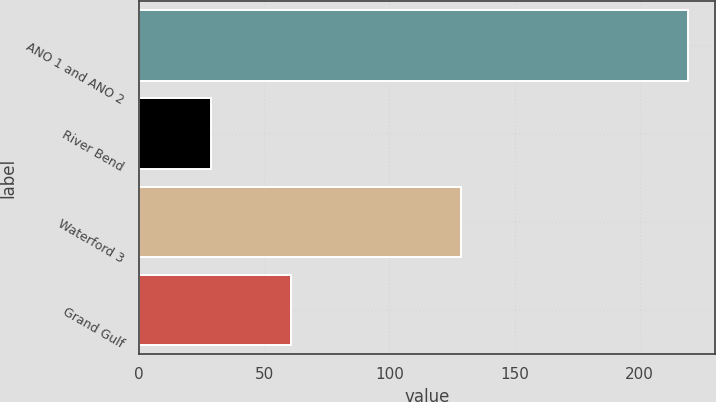Convert chart. <chart><loc_0><loc_0><loc_500><loc_500><bar_chart><fcel>ANO 1 and ANO 2<fcel>River Bend<fcel>Waterford 3<fcel>Grand Gulf<nl><fcel>219.1<fcel>28.7<fcel>128.5<fcel>60.8<nl></chart> 